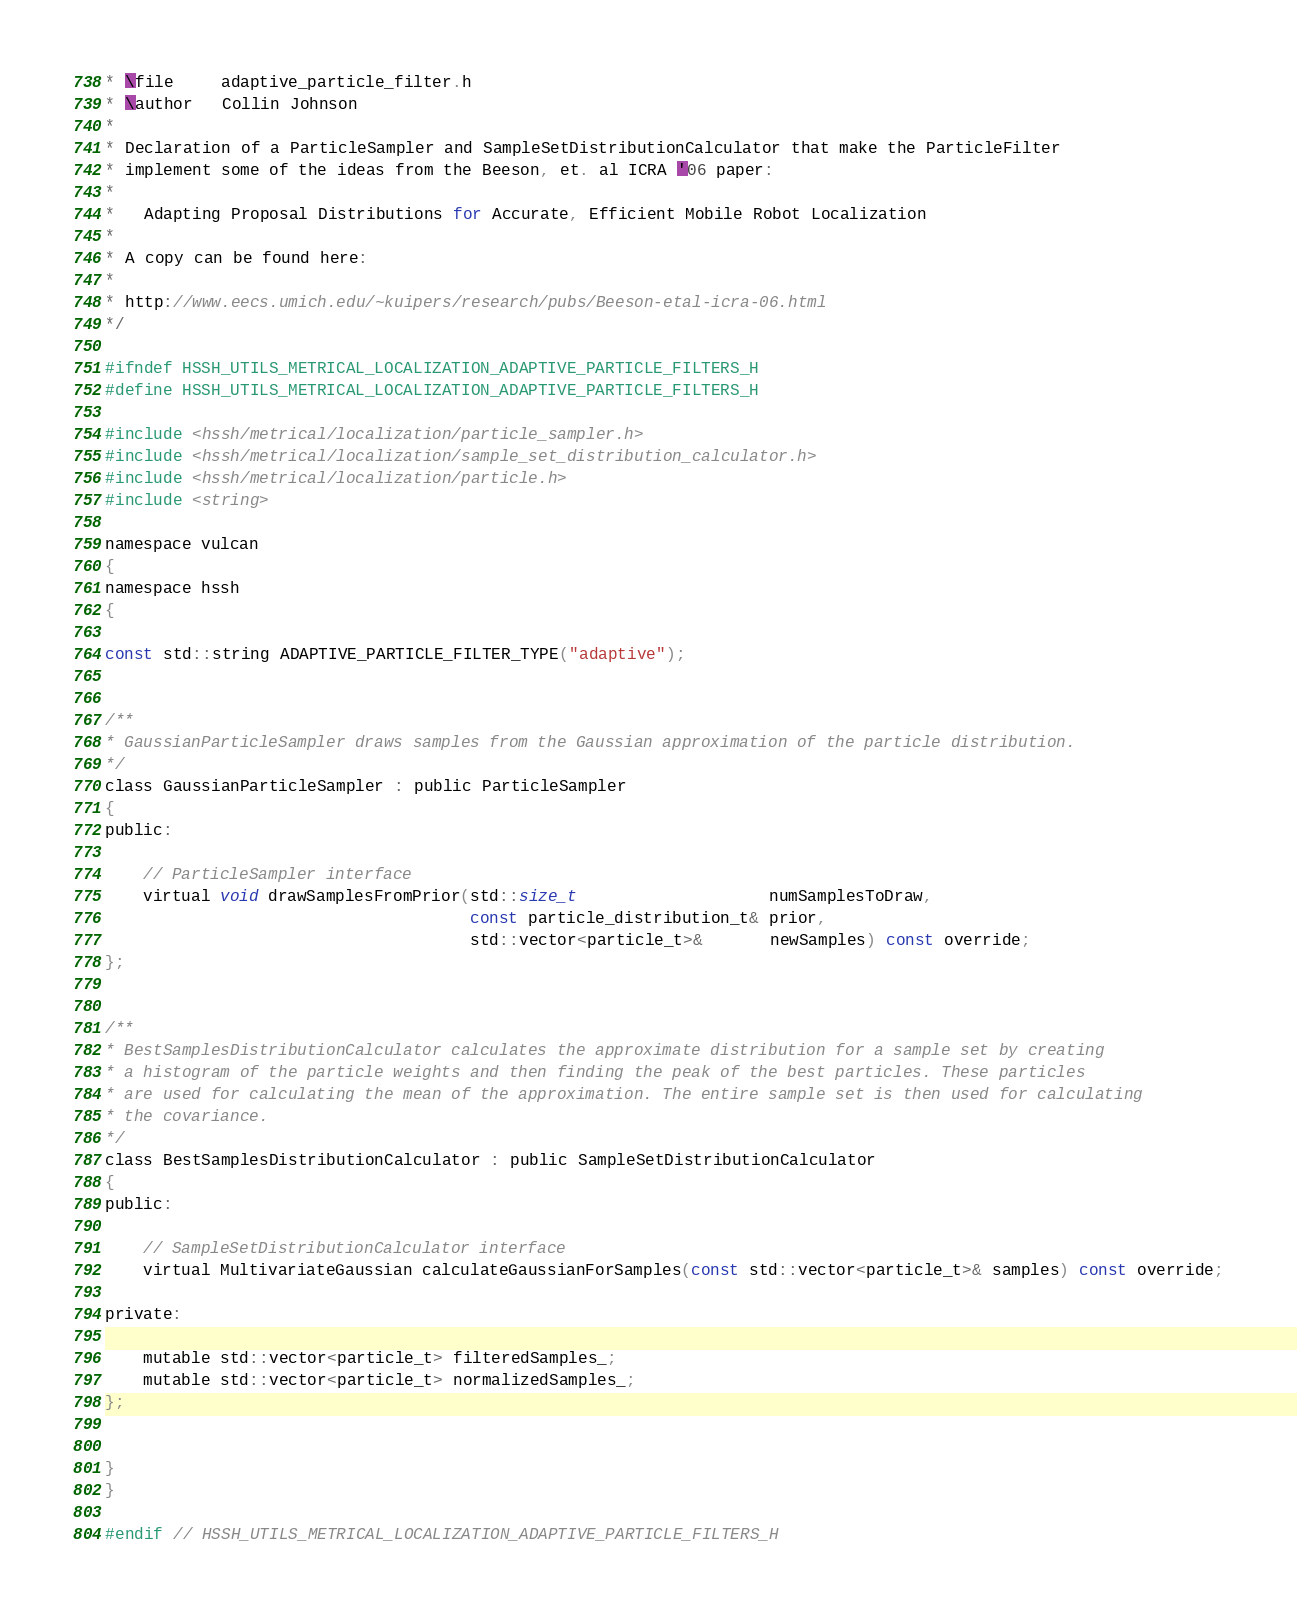<code> <loc_0><loc_0><loc_500><loc_500><_C_>* \file     adaptive_particle_filter.h
* \author   Collin Johnson
*
* Declaration of a ParticleSampler and SampleSetDistributionCalculator that make the ParticleFilter
* implement some of the ideas from the Beeson, et. al ICRA '06 paper:
* 
*   Adapting Proposal Distributions for Accurate, Efficient Mobile Robot Localization
*
* A copy can be found here:
*
* http://www.eecs.umich.edu/~kuipers/research/pubs/Beeson-etal-icra-06.html
*/

#ifndef HSSH_UTILS_METRICAL_LOCALIZATION_ADAPTIVE_PARTICLE_FILTERS_H
#define HSSH_UTILS_METRICAL_LOCALIZATION_ADAPTIVE_PARTICLE_FILTERS_H

#include <hssh/metrical/localization/particle_sampler.h>
#include <hssh/metrical/localization/sample_set_distribution_calculator.h>
#include <hssh/metrical/localization/particle.h>
#include <string>

namespace vulcan
{
namespace hssh
{

const std::string ADAPTIVE_PARTICLE_FILTER_TYPE("adaptive");


/**
* GaussianParticleSampler draws samples from the Gaussian approximation of the particle distribution.
*/
class GaussianParticleSampler : public ParticleSampler
{
public:

    // ParticleSampler interface
    virtual void drawSamplesFromPrior(std::size_t                    numSamplesToDraw,
                                      const particle_distribution_t& prior,
                                      std::vector<particle_t>&       newSamples) const override;
};


/**
* BestSamplesDistributionCalculator calculates the approximate distribution for a sample set by creating
* a histogram of the particle weights and then finding the peak of the best particles. These particles
* are used for calculating the mean of the approximation. The entire sample set is then used for calculating
* the covariance.
*/
class BestSamplesDistributionCalculator : public SampleSetDistributionCalculator
{
public:
    
    // SampleSetDistributionCalculator interface
    virtual MultivariateGaussian calculateGaussianForSamples(const std::vector<particle_t>& samples) const override;
    
private:

    mutable std::vector<particle_t> filteredSamples_;
    mutable std::vector<particle_t> normalizedSamples_;
};


}
}

#endif // HSSH_UTILS_METRICAL_LOCALIZATION_ADAPTIVE_PARTICLE_FILTERS_H
</code> 